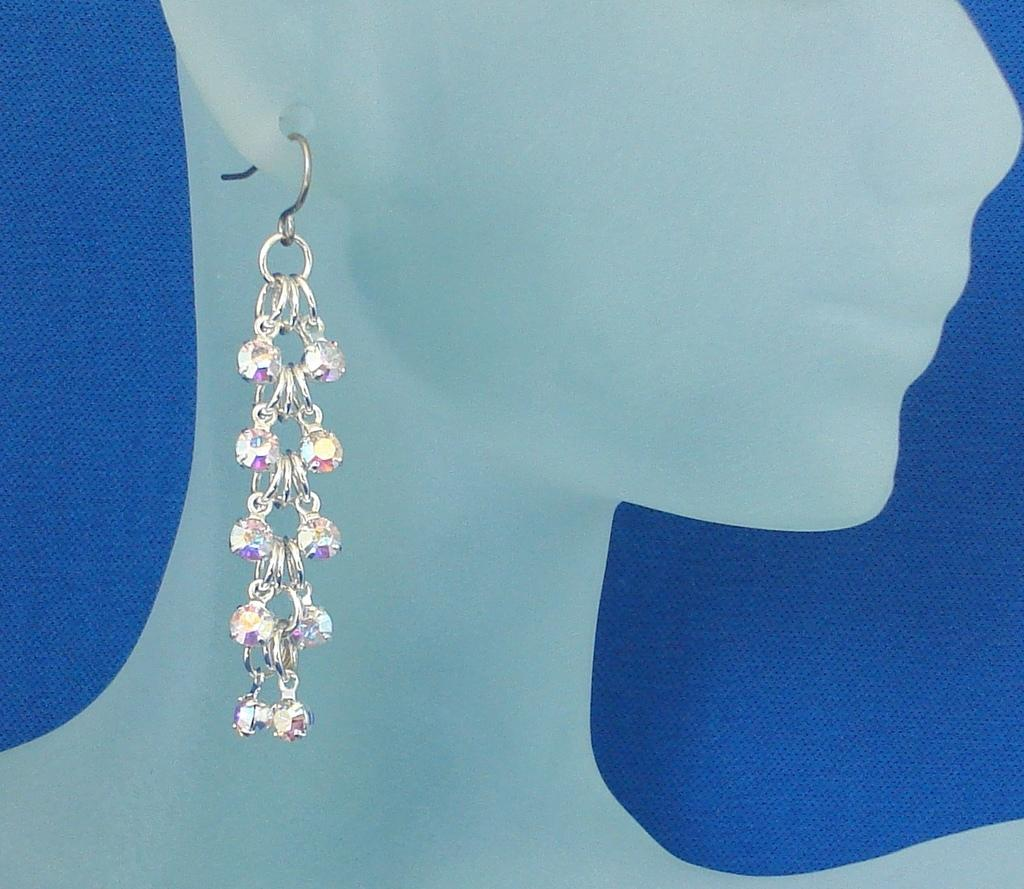What is the main subject in the image? There is a mannequin in the image. What accessory is the mannequin wearing? The mannequin is wearing an earring. What color is the cloth in the background of the image? There is a blue color cloth in the background of the image. What year is depicted in the image? The image does not depict a specific year; it is a still image of a mannequin wearing an earring with a blue cloth in the background. 